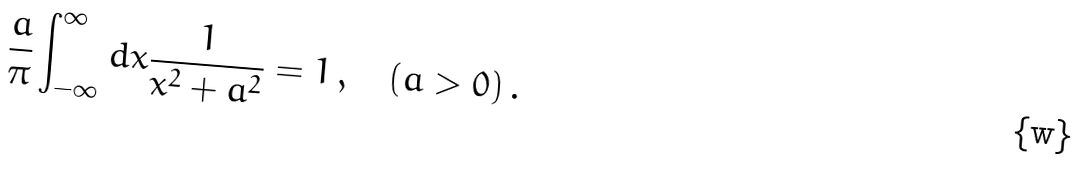<formula> <loc_0><loc_0><loc_500><loc_500>\frac { a } { \pi } \int _ { - \infty } ^ { \infty } d x \frac { 1 } { x ^ { 2 } + a ^ { 2 } } = 1 \, , \quad ( a > 0 ) \, .</formula> 